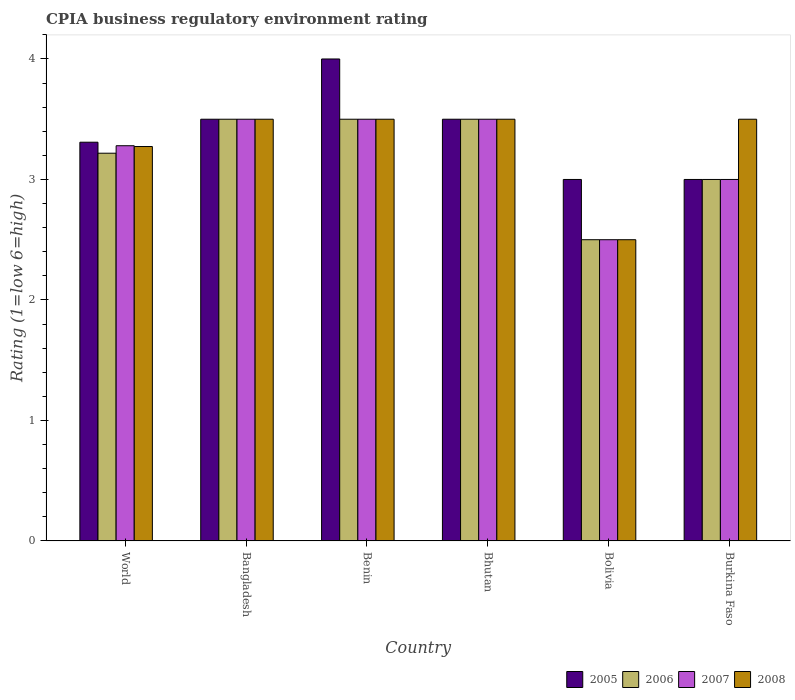Are the number of bars per tick equal to the number of legend labels?
Offer a very short reply. Yes. How many bars are there on the 1st tick from the left?
Give a very brief answer. 4. What is the CPIA rating in 2007 in Benin?
Provide a succinct answer. 3.5. Across all countries, what is the minimum CPIA rating in 2006?
Your answer should be compact. 2.5. What is the total CPIA rating in 2007 in the graph?
Make the answer very short. 19.28. What is the difference between the CPIA rating in 2007 in Bolivia and the CPIA rating in 2006 in Bhutan?
Give a very brief answer. -1. What is the average CPIA rating in 2007 per country?
Provide a succinct answer. 3.21. What is the difference between the CPIA rating of/in 2005 and CPIA rating of/in 2007 in Bolivia?
Keep it short and to the point. 0.5. Is the CPIA rating in 2006 in Bangladesh less than that in Bhutan?
Offer a terse response. No. What is the difference between the highest and the second highest CPIA rating in 2005?
Your response must be concise. -0.5. What is the difference between the highest and the lowest CPIA rating in 2005?
Provide a short and direct response. 1. In how many countries, is the CPIA rating in 2007 greater than the average CPIA rating in 2007 taken over all countries?
Ensure brevity in your answer.  4. Is it the case that in every country, the sum of the CPIA rating in 2006 and CPIA rating in 2008 is greater than the sum of CPIA rating in 2005 and CPIA rating in 2007?
Your answer should be compact. No. What does the 2nd bar from the right in Bangladesh represents?
Ensure brevity in your answer.  2007. Is it the case that in every country, the sum of the CPIA rating in 2008 and CPIA rating in 2006 is greater than the CPIA rating in 2005?
Give a very brief answer. Yes. Does the graph contain grids?
Provide a succinct answer. No. How many legend labels are there?
Offer a very short reply. 4. What is the title of the graph?
Offer a terse response. CPIA business regulatory environment rating. What is the label or title of the Y-axis?
Your answer should be very brief. Rating (1=low 6=high). What is the Rating (1=low 6=high) in 2005 in World?
Provide a succinct answer. 3.31. What is the Rating (1=low 6=high) of 2006 in World?
Ensure brevity in your answer.  3.22. What is the Rating (1=low 6=high) of 2007 in World?
Give a very brief answer. 3.28. What is the Rating (1=low 6=high) in 2008 in World?
Make the answer very short. 3.27. What is the Rating (1=low 6=high) of 2005 in Bangladesh?
Keep it short and to the point. 3.5. What is the Rating (1=low 6=high) of 2008 in Bangladesh?
Offer a very short reply. 3.5. What is the Rating (1=low 6=high) of 2005 in Benin?
Provide a succinct answer. 4. What is the Rating (1=low 6=high) in 2006 in Benin?
Provide a short and direct response. 3.5. What is the Rating (1=low 6=high) in 2007 in Benin?
Offer a very short reply. 3.5. What is the Rating (1=low 6=high) in 2006 in Burkina Faso?
Provide a short and direct response. 3. Across all countries, what is the maximum Rating (1=low 6=high) in 2005?
Offer a terse response. 4. Across all countries, what is the maximum Rating (1=low 6=high) of 2006?
Provide a succinct answer. 3.5. Across all countries, what is the minimum Rating (1=low 6=high) in 2007?
Ensure brevity in your answer.  2.5. Across all countries, what is the minimum Rating (1=low 6=high) in 2008?
Your response must be concise. 2.5. What is the total Rating (1=low 6=high) of 2005 in the graph?
Your answer should be compact. 20.31. What is the total Rating (1=low 6=high) of 2006 in the graph?
Make the answer very short. 19.22. What is the total Rating (1=low 6=high) in 2007 in the graph?
Provide a short and direct response. 19.28. What is the total Rating (1=low 6=high) of 2008 in the graph?
Provide a short and direct response. 19.77. What is the difference between the Rating (1=low 6=high) in 2005 in World and that in Bangladesh?
Give a very brief answer. -0.19. What is the difference between the Rating (1=low 6=high) in 2006 in World and that in Bangladesh?
Offer a very short reply. -0.28. What is the difference between the Rating (1=low 6=high) of 2007 in World and that in Bangladesh?
Give a very brief answer. -0.22. What is the difference between the Rating (1=low 6=high) in 2008 in World and that in Bangladesh?
Provide a succinct answer. -0.23. What is the difference between the Rating (1=low 6=high) of 2005 in World and that in Benin?
Offer a very short reply. -0.69. What is the difference between the Rating (1=low 6=high) in 2006 in World and that in Benin?
Your answer should be compact. -0.28. What is the difference between the Rating (1=low 6=high) of 2007 in World and that in Benin?
Your answer should be compact. -0.22. What is the difference between the Rating (1=low 6=high) in 2008 in World and that in Benin?
Offer a very short reply. -0.23. What is the difference between the Rating (1=low 6=high) in 2005 in World and that in Bhutan?
Offer a terse response. -0.19. What is the difference between the Rating (1=low 6=high) in 2006 in World and that in Bhutan?
Provide a short and direct response. -0.28. What is the difference between the Rating (1=low 6=high) in 2007 in World and that in Bhutan?
Your response must be concise. -0.22. What is the difference between the Rating (1=low 6=high) in 2008 in World and that in Bhutan?
Your answer should be very brief. -0.23. What is the difference between the Rating (1=low 6=high) in 2005 in World and that in Bolivia?
Provide a short and direct response. 0.31. What is the difference between the Rating (1=low 6=high) of 2006 in World and that in Bolivia?
Your answer should be very brief. 0.72. What is the difference between the Rating (1=low 6=high) of 2007 in World and that in Bolivia?
Your answer should be very brief. 0.78. What is the difference between the Rating (1=low 6=high) in 2008 in World and that in Bolivia?
Your response must be concise. 0.77. What is the difference between the Rating (1=low 6=high) in 2005 in World and that in Burkina Faso?
Provide a succinct answer. 0.31. What is the difference between the Rating (1=low 6=high) of 2006 in World and that in Burkina Faso?
Ensure brevity in your answer.  0.22. What is the difference between the Rating (1=low 6=high) in 2007 in World and that in Burkina Faso?
Offer a terse response. 0.28. What is the difference between the Rating (1=low 6=high) in 2008 in World and that in Burkina Faso?
Provide a succinct answer. -0.23. What is the difference between the Rating (1=low 6=high) in 2005 in Bangladesh and that in Benin?
Make the answer very short. -0.5. What is the difference between the Rating (1=low 6=high) of 2006 in Bangladesh and that in Benin?
Your answer should be very brief. 0. What is the difference between the Rating (1=low 6=high) in 2007 in Bangladesh and that in Bhutan?
Your answer should be very brief. 0. What is the difference between the Rating (1=low 6=high) of 2008 in Bangladesh and that in Bhutan?
Give a very brief answer. 0. What is the difference between the Rating (1=low 6=high) of 2007 in Bangladesh and that in Bolivia?
Your answer should be compact. 1. What is the difference between the Rating (1=low 6=high) in 2005 in Bangladesh and that in Burkina Faso?
Offer a very short reply. 0.5. What is the difference between the Rating (1=low 6=high) of 2007 in Benin and that in Bhutan?
Provide a succinct answer. 0. What is the difference between the Rating (1=low 6=high) of 2005 in Benin and that in Bolivia?
Provide a short and direct response. 1. What is the difference between the Rating (1=low 6=high) of 2006 in Benin and that in Bolivia?
Give a very brief answer. 1. What is the difference between the Rating (1=low 6=high) of 2007 in Benin and that in Bolivia?
Your answer should be compact. 1. What is the difference between the Rating (1=low 6=high) of 2008 in Benin and that in Bolivia?
Your answer should be very brief. 1. What is the difference between the Rating (1=low 6=high) of 2005 in Benin and that in Burkina Faso?
Provide a short and direct response. 1. What is the difference between the Rating (1=low 6=high) in 2006 in Benin and that in Burkina Faso?
Keep it short and to the point. 0.5. What is the difference between the Rating (1=low 6=high) of 2007 in Benin and that in Burkina Faso?
Make the answer very short. 0.5. What is the difference between the Rating (1=low 6=high) in 2008 in Benin and that in Burkina Faso?
Offer a terse response. 0. What is the difference between the Rating (1=low 6=high) in 2005 in Bhutan and that in Bolivia?
Keep it short and to the point. 0.5. What is the difference between the Rating (1=low 6=high) in 2007 in Bhutan and that in Bolivia?
Your response must be concise. 1. What is the difference between the Rating (1=low 6=high) in 2008 in Bhutan and that in Bolivia?
Ensure brevity in your answer.  1. What is the difference between the Rating (1=low 6=high) in 2005 in Bhutan and that in Burkina Faso?
Your answer should be compact. 0.5. What is the difference between the Rating (1=low 6=high) in 2007 in Bhutan and that in Burkina Faso?
Give a very brief answer. 0.5. What is the difference between the Rating (1=low 6=high) of 2008 in Bhutan and that in Burkina Faso?
Your response must be concise. 0. What is the difference between the Rating (1=low 6=high) of 2007 in Bolivia and that in Burkina Faso?
Keep it short and to the point. -0.5. What is the difference between the Rating (1=low 6=high) of 2005 in World and the Rating (1=low 6=high) of 2006 in Bangladesh?
Offer a terse response. -0.19. What is the difference between the Rating (1=low 6=high) of 2005 in World and the Rating (1=low 6=high) of 2007 in Bangladesh?
Offer a very short reply. -0.19. What is the difference between the Rating (1=low 6=high) in 2005 in World and the Rating (1=low 6=high) in 2008 in Bangladesh?
Your answer should be compact. -0.19. What is the difference between the Rating (1=low 6=high) in 2006 in World and the Rating (1=low 6=high) in 2007 in Bangladesh?
Offer a very short reply. -0.28. What is the difference between the Rating (1=low 6=high) in 2006 in World and the Rating (1=low 6=high) in 2008 in Bangladesh?
Offer a terse response. -0.28. What is the difference between the Rating (1=low 6=high) of 2007 in World and the Rating (1=low 6=high) of 2008 in Bangladesh?
Give a very brief answer. -0.22. What is the difference between the Rating (1=low 6=high) in 2005 in World and the Rating (1=low 6=high) in 2006 in Benin?
Provide a succinct answer. -0.19. What is the difference between the Rating (1=low 6=high) in 2005 in World and the Rating (1=low 6=high) in 2007 in Benin?
Provide a short and direct response. -0.19. What is the difference between the Rating (1=low 6=high) in 2005 in World and the Rating (1=low 6=high) in 2008 in Benin?
Keep it short and to the point. -0.19. What is the difference between the Rating (1=low 6=high) in 2006 in World and the Rating (1=low 6=high) in 2007 in Benin?
Provide a short and direct response. -0.28. What is the difference between the Rating (1=low 6=high) of 2006 in World and the Rating (1=low 6=high) of 2008 in Benin?
Give a very brief answer. -0.28. What is the difference between the Rating (1=low 6=high) in 2007 in World and the Rating (1=low 6=high) in 2008 in Benin?
Provide a short and direct response. -0.22. What is the difference between the Rating (1=low 6=high) in 2005 in World and the Rating (1=low 6=high) in 2006 in Bhutan?
Your response must be concise. -0.19. What is the difference between the Rating (1=low 6=high) of 2005 in World and the Rating (1=low 6=high) of 2007 in Bhutan?
Ensure brevity in your answer.  -0.19. What is the difference between the Rating (1=low 6=high) in 2005 in World and the Rating (1=low 6=high) in 2008 in Bhutan?
Keep it short and to the point. -0.19. What is the difference between the Rating (1=low 6=high) of 2006 in World and the Rating (1=low 6=high) of 2007 in Bhutan?
Your answer should be very brief. -0.28. What is the difference between the Rating (1=low 6=high) of 2006 in World and the Rating (1=low 6=high) of 2008 in Bhutan?
Provide a succinct answer. -0.28. What is the difference between the Rating (1=low 6=high) of 2007 in World and the Rating (1=low 6=high) of 2008 in Bhutan?
Your response must be concise. -0.22. What is the difference between the Rating (1=low 6=high) in 2005 in World and the Rating (1=low 6=high) in 2006 in Bolivia?
Offer a terse response. 0.81. What is the difference between the Rating (1=low 6=high) in 2005 in World and the Rating (1=low 6=high) in 2007 in Bolivia?
Your answer should be compact. 0.81. What is the difference between the Rating (1=low 6=high) in 2005 in World and the Rating (1=low 6=high) in 2008 in Bolivia?
Ensure brevity in your answer.  0.81. What is the difference between the Rating (1=low 6=high) in 2006 in World and the Rating (1=low 6=high) in 2007 in Bolivia?
Offer a very short reply. 0.72. What is the difference between the Rating (1=low 6=high) of 2006 in World and the Rating (1=low 6=high) of 2008 in Bolivia?
Your answer should be very brief. 0.72. What is the difference between the Rating (1=low 6=high) of 2007 in World and the Rating (1=low 6=high) of 2008 in Bolivia?
Your response must be concise. 0.78. What is the difference between the Rating (1=low 6=high) of 2005 in World and the Rating (1=low 6=high) of 2006 in Burkina Faso?
Make the answer very short. 0.31. What is the difference between the Rating (1=low 6=high) of 2005 in World and the Rating (1=low 6=high) of 2007 in Burkina Faso?
Provide a short and direct response. 0.31. What is the difference between the Rating (1=low 6=high) of 2005 in World and the Rating (1=low 6=high) of 2008 in Burkina Faso?
Offer a very short reply. -0.19. What is the difference between the Rating (1=low 6=high) of 2006 in World and the Rating (1=low 6=high) of 2007 in Burkina Faso?
Give a very brief answer. 0.22. What is the difference between the Rating (1=low 6=high) of 2006 in World and the Rating (1=low 6=high) of 2008 in Burkina Faso?
Provide a short and direct response. -0.28. What is the difference between the Rating (1=low 6=high) of 2007 in World and the Rating (1=low 6=high) of 2008 in Burkina Faso?
Provide a succinct answer. -0.22. What is the difference between the Rating (1=low 6=high) of 2006 in Bangladesh and the Rating (1=low 6=high) of 2008 in Benin?
Offer a terse response. 0. What is the difference between the Rating (1=low 6=high) in 2007 in Bangladesh and the Rating (1=low 6=high) in 2008 in Benin?
Provide a short and direct response. 0. What is the difference between the Rating (1=low 6=high) of 2005 in Bangladesh and the Rating (1=low 6=high) of 2007 in Bhutan?
Your answer should be compact. 0. What is the difference between the Rating (1=low 6=high) in 2005 in Bangladesh and the Rating (1=low 6=high) in 2008 in Bhutan?
Provide a succinct answer. 0. What is the difference between the Rating (1=low 6=high) of 2006 in Bangladesh and the Rating (1=low 6=high) of 2007 in Bhutan?
Provide a short and direct response. 0. What is the difference between the Rating (1=low 6=high) of 2006 in Bangladesh and the Rating (1=low 6=high) of 2008 in Bhutan?
Ensure brevity in your answer.  0. What is the difference between the Rating (1=low 6=high) in 2007 in Bangladesh and the Rating (1=low 6=high) in 2008 in Bhutan?
Your answer should be very brief. 0. What is the difference between the Rating (1=low 6=high) in 2005 in Bangladesh and the Rating (1=low 6=high) in 2006 in Bolivia?
Offer a very short reply. 1. What is the difference between the Rating (1=low 6=high) of 2005 in Bangladesh and the Rating (1=low 6=high) of 2008 in Bolivia?
Your answer should be compact. 1. What is the difference between the Rating (1=low 6=high) in 2006 in Bangladesh and the Rating (1=low 6=high) in 2007 in Bolivia?
Provide a short and direct response. 1. What is the difference between the Rating (1=low 6=high) of 2006 in Bangladesh and the Rating (1=low 6=high) of 2008 in Bolivia?
Your answer should be very brief. 1. What is the difference between the Rating (1=low 6=high) in 2007 in Bangladesh and the Rating (1=low 6=high) in 2008 in Bolivia?
Your answer should be compact. 1. What is the difference between the Rating (1=low 6=high) in 2005 in Bangladesh and the Rating (1=low 6=high) in 2006 in Burkina Faso?
Offer a terse response. 0.5. What is the difference between the Rating (1=low 6=high) in 2005 in Bangladesh and the Rating (1=low 6=high) in 2007 in Burkina Faso?
Provide a succinct answer. 0.5. What is the difference between the Rating (1=low 6=high) of 2005 in Bangladesh and the Rating (1=low 6=high) of 2008 in Burkina Faso?
Keep it short and to the point. 0. What is the difference between the Rating (1=low 6=high) in 2006 in Bangladesh and the Rating (1=low 6=high) in 2007 in Burkina Faso?
Your answer should be compact. 0.5. What is the difference between the Rating (1=low 6=high) of 2007 in Bangladesh and the Rating (1=low 6=high) of 2008 in Burkina Faso?
Your response must be concise. 0. What is the difference between the Rating (1=low 6=high) of 2006 in Benin and the Rating (1=low 6=high) of 2007 in Bhutan?
Make the answer very short. 0. What is the difference between the Rating (1=low 6=high) in 2006 in Benin and the Rating (1=low 6=high) in 2008 in Bhutan?
Offer a terse response. 0. What is the difference between the Rating (1=low 6=high) in 2007 in Benin and the Rating (1=low 6=high) in 2008 in Bhutan?
Make the answer very short. 0. What is the difference between the Rating (1=low 6=high) in 2005 in Benin and the Rating (1=low 6=high) in 2007 in Bolivia?
Your answer should be very brief. 1.5. What is the difference between the Rating (1=low 6=high) of 2005 in Benin and the Rating (1=low 6=high) of 2008 in Bolivia?
Keep it short and to the point. 1.5. What is the difference between the Rating (1=low 6=high) of 2006 in Benin and the Rating (1=low 6=high) of 2007 in Bolivia?
Keep it short and to the point. 1. What is the difference between the Rating (1=low 6=high) of 2006 in Benin and the Rating (1=low 6=high) of 2008 in Bolivia?
Your response must be concise. 1. What is the difference between the Rating (1=low 6=high) in 2005 in Benin and the Rating (1=low 6=high) in 2006 in Burkina Faso?
Your answer should be very brief. 1. What is the difference between the Rating (1=low 6=high) of 2006 in Benin and the Rating (1=low 6=high) of 2008 in Burkina Faso?
Offer a very short reply. 0. What is the difference between the Rating (1=low 6=high) in 2005 in Bhutan and the Rating (1=low 6=high) in 2006 in Bolivia?
Ensure brevity in your answer.  1. What is the difference between the Rating (1=low 6=high) of 2005 in Bhutan and the Rating (1=low 6=high) of 2007 in Bolivia?
Ensure brevity in your answer.  1. What is the difference between the Rating (1=low 6=high) in 2005 in Bhutan and the Rating (1=low 6=high) in 2008 in Bolivia?
Keep it short and to the point. 1. What is the difference between the Rating (1=low 6=high) in 2006 in Bhutan and the Rating (1=low 6=high) in 2007 in Bolivia?
Make the answer very short. 1. What is the difference between the Rating (1=low 6=high) in 2007 in Bhutan and the Rating (1=low 6=high) in 2008 in Bolivia?
Make the answer very short. 1. What is the difference between the Rating (1=low 6=high) of 2005 in Bhutan and the Rating (1=low 6=high) of 2006 in Burkina Faso?
Offer a terse response. 0.5. What is the difference between the Rating (1=low 6=high) of 2005 in Bhutan and the Rating (1=low 6=high) of 2008 in Burkina Faso?
Offer a terse response. 0. What is the difference between the Rating (1=low 6=high) of 2006 in Bhutan and the Rating (1=low 6=high) of 2007 in Burkina Faso?
Make the answer very short. 0.5. What is the difference between the Rating (1=low 6=high) of 2007 in Bhutan and the Rating (1=low 6=high) of 2008 in Burkina Faso?
Ensure brevity in your answer.  0. What is the difference between the Rating (1=low 6=high) of 2006 in Bolivia and the Rating (1=low 6=high) of 2007 in Burkina Faso?
Give a very brief answer. -0.5. What is the difference between the Rating (1=low 6=high) of 2006 in Bolivia and the Rating (1=low 6=high) of 2008 in Burkina Faso?
Ensure brevity in your answer.  -1. What is the average Rating (1=low 6=high) of 2005 per country?
Ensure brevity in your answer.  3.38. What is the average Rating (1=low 6=high) in 2006 per country?
Provide a short and direct response. 3.2. What is the average Rating (1=low 6=high) of 2007 per country?
Your answer should be very brief. 3.21. What is the average Rating (1=low 6=high) of 2008 per country?
Provide a succinct answer. 3.3. What is the difference between the Rating (1=low 6=high) of 2005 and Rating (1=low 6=high) of 2006 in World?
Provide a succinct answer. 0.09. What is the difference between the Rating (1=low 6=high) in 2005 and Rating (1=low 6=high) in 2007 in World?
Make the answer very short. 0.03. What is the difference between the Rating (1=low 6=high) of 2005 and Rating (1=low 6=high) of 2008 in World?
Keep it short and to the point. 0.04. What is the difference between the Rating (1=low 6=high) of 2006 and Rating (1=low 6=high) of 2007 in World?
Offer a very short reply. -0.06. What is the difference between the Rating (1=low 6=high) in 2006 and Rating (1=low 6=high) in 2008 in World?
Your response must be concise. -0.06. What is the difference between the Rating (1=low 6=high) of 2007 and Rating (1=low 6=high) of 2008 in World?
Provide a succinct answer. 0.01. What is the difference between the Rating (1=low 6=high) in 2005 and Rating (1=low 6=high) in 2008 in Bangladesh?
Your response must be concise. 0. What is the difference between the Rating (1=low 6=high) in 2006 and Rating (1=low 6=high) in 2007 in Bangladesh?
Give a very brief answer. 0. What is the difference between the Rating (1=low 6=high) of 2005 and Rating (1=low 6=high) of 2008 in Benin?
Provide a short and direct response. 0.5. What is the difference between the Rating (1=low 6=high) of 2006 and Rating (1=low 6=high) of 2007 in Benin?
Provide a short and direct response. 0. What is the difference between the Rating (1=low 6=high) in 2007 and Rating (1=low 6=high) in 2008 in Benin?
Offer a very short reply. 0. What is the difference between the Rating (1=low 6=high) of 2006 and Rating (1=low 6=high) of 2008 in Bhutan?
Ensure brevity in your answer.  0. What is the difference between the Rating (1=low 6=high) of 2005 and Rating (1=low 6=high) of 2006 in Bolivia?
Give a very brief answer. 0.5. What is the difference between the Rating (1=low 6=high) in 2005 and Rating (1=low 6=high) in 2007 in Bolivia?
Make the answer very short. 0.5. What is the difference between the Rating (1=low 6=high) in 2005 and Rating (1=low 6=high) in 2008 in Burkina Faso?
Offer a very short reply. -0.5. What is the difference between the Rating (1=low 6=high) in 2006 and Rating (1=low 6=high) in 2007 in Burkina Faso?
Your answer should be very brief. 0. What is the difference between the Rating (1=low 6=high) of 2006 and Rating (1=low 6=high) of 2008 in Burkina Faso?
Provide a succinct answer. -0.5. What is the difference between the Rating (1=low 6=high) in 2007 and Rating (1=low 6=high) in 2008 in Burkina Faso?
Make the answer very short. -0.5. What is the ratio of the Rating (1=low 6=high) of 2005 in World to that in Bangladesh?
Provide a short and direct response. 0.95. What is the ratio of the Rating (1=low 6=high) of 2006 in World to that in Bangladesh?
Your answer should be very brief. 0.92. What is the ratio of the Rating (1=low 6=high) in 2007 in World to that in Bangladesh?
Your response must be concise. 0.94. What is the ratio of the Rating (1=low 6=high) of 2008 in World to that in Bangladesh?
Offer a very short reply. 0.94. What is the ratio of the Rating (1=low 6=high) in 2005 in World to that in Benin?
Give a very brief answer. 0.83. What is the ratio of the Rating (1=low 6=high) in 2006 in World to that in Benin?
Provide a succinct answer. 0.92. What is the ratio of the Rating (1=low 6=high) of 2007 in World to that in Benin?
Your answer should be very brief. 0.94. What is the ratio of the Rating (1=low 6=high) of 2008 in World to that in Benin?
Your answer should be very brief. 0.94. What is the ratio of the Rating (1=low 6=high) in 2005 in World to that in Bhutan?
Keep it short and to the point. 0.95. What is the ratio of the Rating (1=low 6=high) of 2006 in World to that in Bhutan?
Your response must be concise. 0.92. What is the ratio of the Rating (1=low 6=high) in 2007 in World to that in Bhutan?
Keep it short and to the point. 0.94. What is the ratio of the Rating (1=low 6=high) of 2008 in World to that in Bhutan?
Keep it short and to the point. 0.94. What is the ratio of the Rating (1=low 6=high) of 2005 in World to that in Bolivia?
Give a very brief answer. 1.1. What is the ratio of the Rating (1=low 6=high) in 2006 in World to that in Bolivia?
Give a very brief answer. 1.29. What is the ratio of the Rating (1=low 6=high) in 2007 in World to that in Bolivia?
Provide a short and direct response. 1.31. What is the ratio of the Rating (1=low 6=high) of 2008 in World to that in Bolivia?
Offer a terse response. 1.31. What is the ratio of the Rating (1=low 6=high) of 2005 in World to that in Burkina Faso?
Your response must be concise. 1.1. What is the ratio of the Rating (1=low 6=high) in 2006 in World to that in Burkina Faso?
Keep it short and to the point. 1.07. What is the ratio of the Rating (1=low 6=high) of 2007 in World to that in Burkina Faso?
Keep it short and to the point. 1.09. What is the ratio of the Rating (1=low 6=high) of 2008 in World to that in Burkina Faso?
Keep it short and to the point. 0.94. What is the ratio of the Rating (1=low 6=high) of 2005 in Bangladesh to that in Benin?
Offer a very short reply. 0.88. What is the ratio of the Rating (1=low 6=high) of 2007 in Bangladesh to that in Benin?
Offer a terse response. 1. What is the ratio of the Rating (1=low 6=high) in 2008 in Bangladesh to that in Benin?
Your answer should be compact. 1. What is the ratio of the Rating (1=low 6=high) in 2005 in Bangladesh to that in Bhutan?
Keep it short and to the point. 1. What is the ratio of the Rating (1=low 6=high) in 2006 in Bangladesh to that in Bhutan?
Keep it short and to the point. 1. What is the ratio of the Rating (1=low 6=high) of 2008 in Bangladesh to that in Bhutan?
Provide a succinct answer. 1. What is the ratio of the Rating (1=low 6=high) of 2005 in Bangladesh to that in Bolivia?
Give a very brief answer. 1.17. What is the ratio of the Rating (1=low 6=high) in 2006 in Bangladesh to that in Bolivia?
Offer a very short reply. 1.4. What is the ratio of the Rating (1=low 6=high) of 2008 in Bangladesh to that in Bolivia?
Offer a very short reply. 1.4. What is the ratio of the Rating (1=low 6=high) in 2006 in Bangladesh to that in Burkina Faso?
Offer a very short reply. 1.17. What is the ratio of the Rating (1=low 6=high) of 2007 in Bangladesh to that in Burkina Faso?
Make the answer very short. 1.17. What is the ratio of the Rating (1=low 6=high) of 2006 in Benin to that in Bhutan?
Offer a very short reply. 1. What is the ratio of the Rating (1=low 6=high) in 2007 in Benin to that in Bhutan?
Give a very brief answer. 1. What is the ratio of the Rating (1=low 6=high) of 2005 in Benin to that in Bolivia?
Keep it short and to the point. 1.33. What is the ratio of the Rating (1=low 6=high) of 2005 in Benin to that in Burkina Faso?
Give a very brief answer. 1.33. What is the ratio of the Rating (1=low 6=high) of 2005 in Bhutan to that in Bolivia?
Provide a short and direct response. 1.17. What is the ratio of the Rating (1=low 6=high) of 2005 in Bhutan to that in Burkina Faso?
Your answer should be compact. 1.17. What is the ratio of the Rating (1=low 6=high) of 2005 in Bolivia to that in Burkina Faso?
Offer a terse response. 1. What is the ratio of the Rating (1=low 6=high) in 2006 in Bolivia to that in Burkina Faso?
Offer a very short reply. 0.83. What is the difference between the highest and the second highest Rating (1=low 6=high) in 2005?
Offer a terse response. 0.5. What is the difference between the highest and the second highest Rating (1=low 6=high) of 2006?
Offer a very short reply. 0. What is the difference between the highest and the second highest Rating (1=low 6=high) of 2008?
Provide a short and direct response. 0. What is the difference between the highest and the lowest Rating (1=low 6=high) of 2005?
Your answer should be compact. 1. 